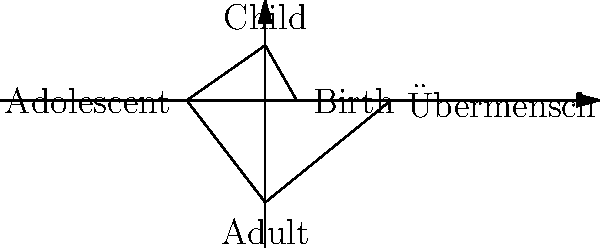In the context of Nietzsche's philosophy, analyze the spiral progression depicted in the image. How does this representation reflect the concept of "becoming who you are" through transformative self-portraits, and what artistic techniques could be employed to visually convey the philosophical depth of each stage? 1. Understand the spiral structure: The spiral represents a non-linear progression through life stages, aligning with Nietzsche's idea that personal growth is not a straight path but a continuous process of transformation.

2. Identify the stages: The spiral shows five key stages: Birth, Child, Adolescent, Adult, and Übermensch. These represent the transformative journey in Nietzsche's philosophy.

3. Recognize the concept of "becoming": The spiral's outward movement symbolizes personal growth and self-realization, central to Nietzsche's idea of "becoming who you are."

4. Analyze the Übermensch stage: This final stage represents Nietzsche's ideal of the "overman" or "superman," embodying self-mastery and the creation of one's own values.

5. Consider artistic techniques for self-portraits:
   a. Use of color: Evolve from muted tones to vibrant colors to show increasing self-awareness.
   b. Composition: Progress from confined to expansive layouts, symbolizing growing freedom.
   c. Symbolism: Incorporate symbols relevant to each life stage and Nietzschean concepts.
   d. Style evolution: Move from realistic to more abstract or expressive styles to show deepening self-understanding.
   e. Texture and brushwork: Develop from smooth to more complex textures, reflecting life's increasing complexity.

6. Incorporate philosophical depth:
   a. Birth/Child: Show innocence and potential, using soft lines and simple compositions.
   b. Adolescent: Depict struggle and questioning, with contrasting elements and dynamic brushstrokes.
   c. Adult: Illustrate self-reflection and responsibility, using more structured compositions and deeper tones.
   d. Übermensch: Represent transcendence and self-creation, using bold, unconventional techniques and compositions that break traditional rules.

7. Emphasize transformation: Use visual elements that carry through all portraits but evolve in each stage, symbolizing continuous becoming.
Answer: Spiral progression representing life stages; evolving artistic techniques (color, composition, symbolism, style, texture) to depict growing self-awareness and philosophical depth in self-portraits. 